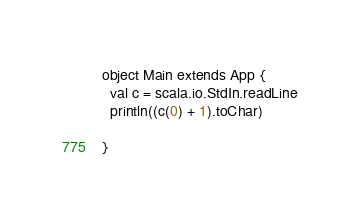Convert code to text. <code><loc_0><loc_0><loc_500><loc_500><_Scala_>object Main extends App {
  val c = scala.io.StdIn.readLine
  println((c(0) + 1).toChar)

}
</code> 